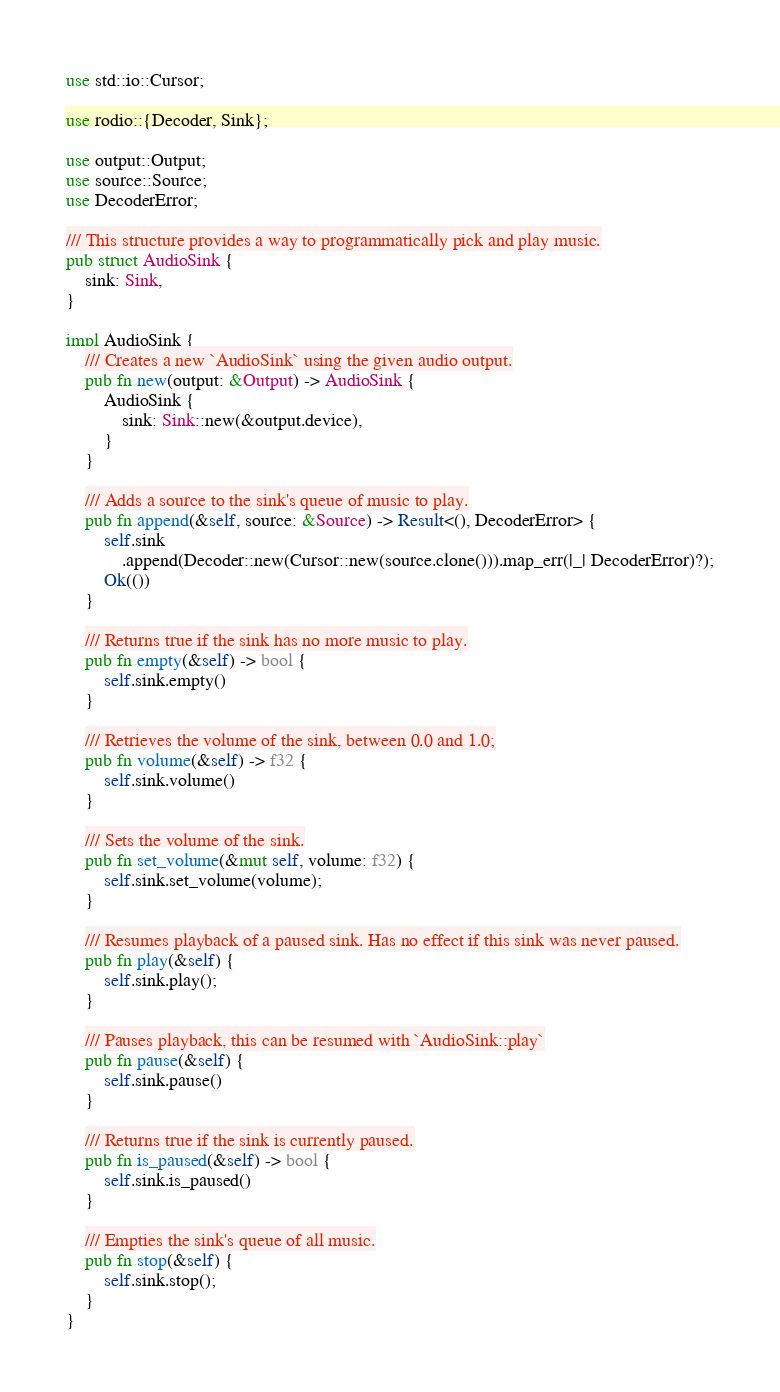<code> <loc_0><loc_0><loc_500><loc_500><_Rust_>use std::io::Cursor;

use rodio::{Decoder, Sink};

use output::Output;
use source::Source;
use DecoderError;

/// This structure provides a way to programmatically pick and play music.
pub struct AudioSink {
    sink: Sink,
}

impl AudioSink {
    /// Creates a new `AudioSink` using the given audio output.
    pub fn new(output: &Output) -> AudioSink {
        AudioSink {
            sink: Sink::new(&output.device),
        }
    }

    /// Adds a source to the sink's queue of music to play.
    pub fn append(&self, source: &Source) -> Result<(), DecoderError> {
        self.sink
            .append(Decoder::new(Cursor::new(source.clone())).map_err(|_| DecoderError)?);
        Ok(())
    }

    /// Returns true if the sink has no more music to play.
    pub fn empty(&self) -> bool {
        self.sink.empty()
    }

    /// Retrieves the volume of the sink, between 0.0 and 1.0;
    pub fn volume(&self) -> f32 {
        self.sink.volume()
    }

    /// Sets the volume of the sink.
    pub fn set_volume(&mut self, volume: f32) {
        self.sink.set_volume(volume);
    }

    /// Resumes playback of a paused sink. Has no effect if this sink was never paused.
    pub fn play(&self) {
        self.sink.play();
    }

    /// Pauses playback, this can be resumed with `AudioSink::play`
    pub fn pause(&self) {
        self.sink.pause()
    }

    /// Returns true if the sink is currently paused.
    pub fn is_paused(&self) -> bool {
        self.sink.is_paused()
    }

    /// Empties the sink's queue of all music.
    pub fn stop(&self) {
        self.sink.stop();
    }
}
</code> 